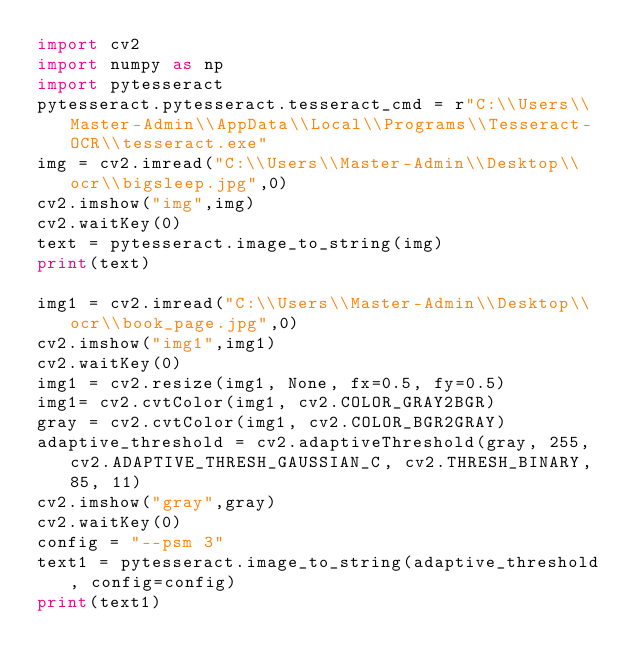Convert code to text. <code><loc_0><loc_0><loc_500><loc_500><_Python_>import cv2
import numpy as np
import pytesseract
pytesseract.pytesseract.tesseract_cmd = r"C:\\Users\\Master-Admin\\AppData\\Local\\Programs\\Tesseract-OCR\\tesseract.exe"
img = cv2.imread("C:\\Users\\Master-Admin\\Desktop\\ocr\\bigsleep.jpg",0)
cv2.imshow("img",img)
cv2.waitKey(0)
text = pytesseract.image_to_string(img)
print(text)

img1 = cv2.imread("C:\\Users\\Master-Admin\\Desktop\\ocr\\book_page.jpg",0)
cv2.imshow("img1",img1)
cv2.waitKey(0)
img1 = cv2.resize(img1, None, fx=0.5, fy=0.5)
img1= cv2.cvtColor(img1, cv2.COLOR_GRAY2BGR)
gray = cv2.cvtColor(img1, cv2.COLOR_BGR2GRAY)
adaptive_threshold = cv2.adaptiveThreshold(gray, 255, cv2.ADAPTIVE_THRESH_GAUSSIAN_C, cv2.THRESH_BINARY, 85, 11)
cv2.imshow("gray",gray)
cv2.waitKey(0)
config = "--psm 3"
text1 = pytesseract.image_to_string(adaptive_threshold, config=config)
print(text1)
</code> 